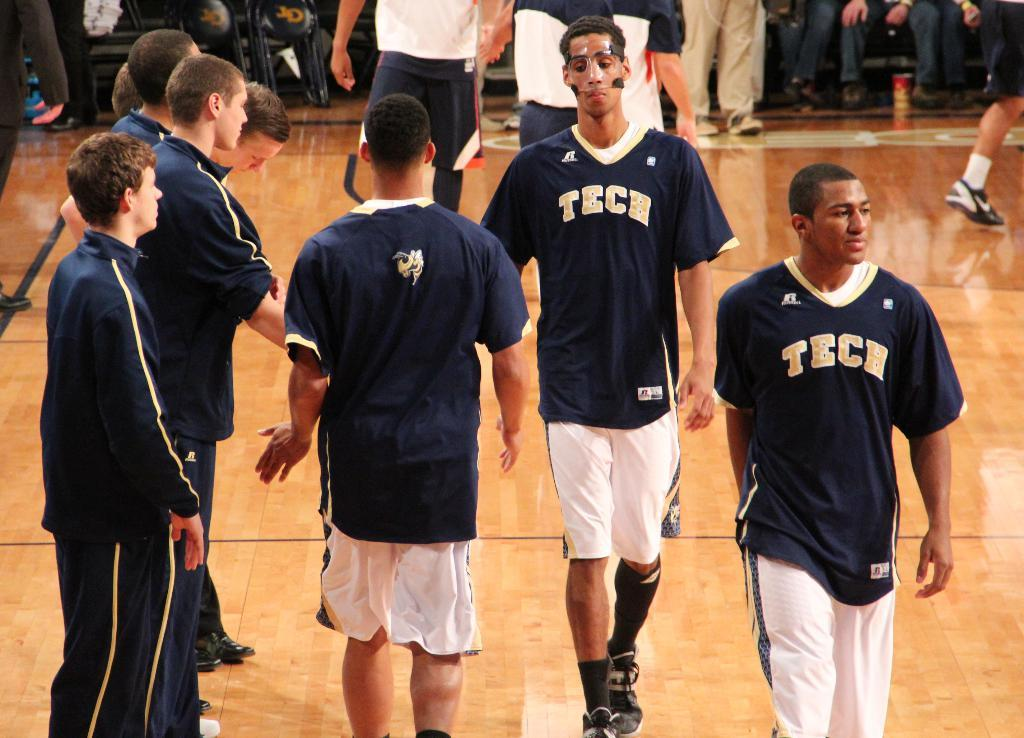What activity is the person in the image engaged in? The person is riding a bicycle on a road. What can be seen in the background of the image? There are cars and buildings in the background. What type of addition problem can be solved using the camera in the image? There is no camera present in the image, and therefore no addition problem can be solved using it. 